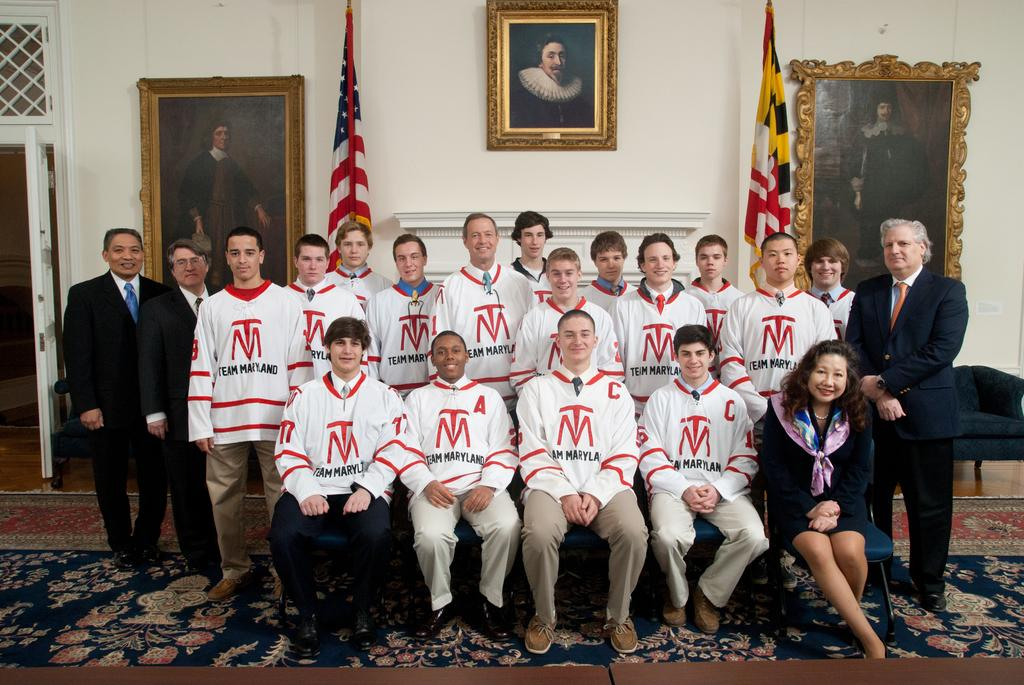Provide a one-sentence caption for the provided image. the letters TM that are on a shirt. 